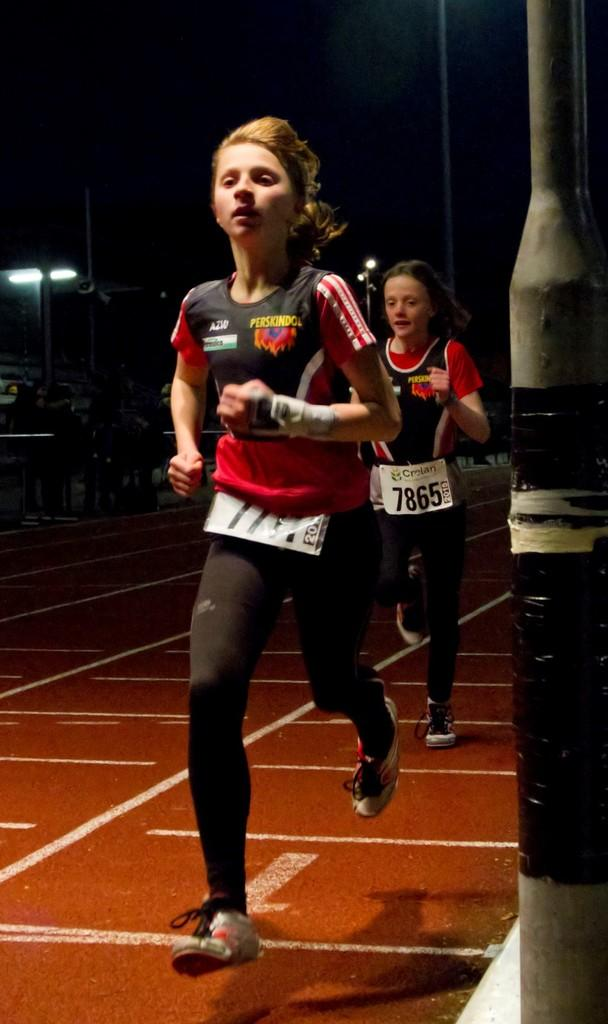How many girls are present in the image? There are 2 girls in the image. What are the girls doing in the image? The girls are running on the ground. What type of bean is growing on the ground where the girls are running? There is no bean plant visible in the image, and the girls are running on the ground, not on a bean plant. 